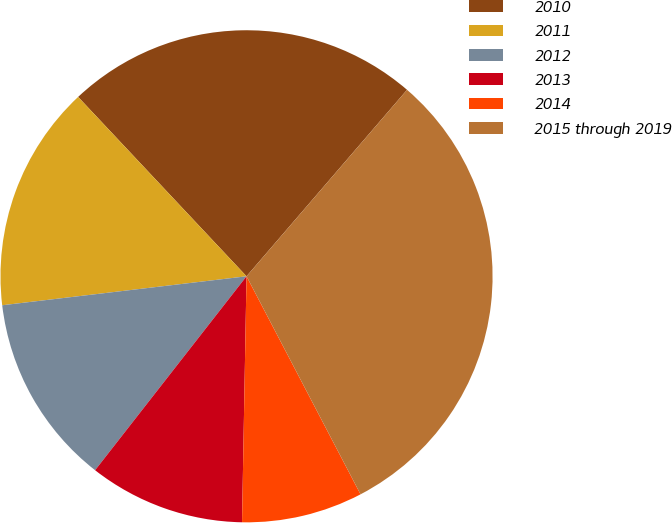Convert chart to OTSL. <chart><loc_0><loc_0><loc_500><loc_500><pie_chart><fcel>2010<fcel>2011<fcel>2012<fcel>2013<fcel>2014<fcel>2015 through 2019<nl><fcel>23.31%<fcel>14.88%<fcel>12.57%<fcel>10.26%<fcel>7.96%<fcel>31.02%<nl></chart> 